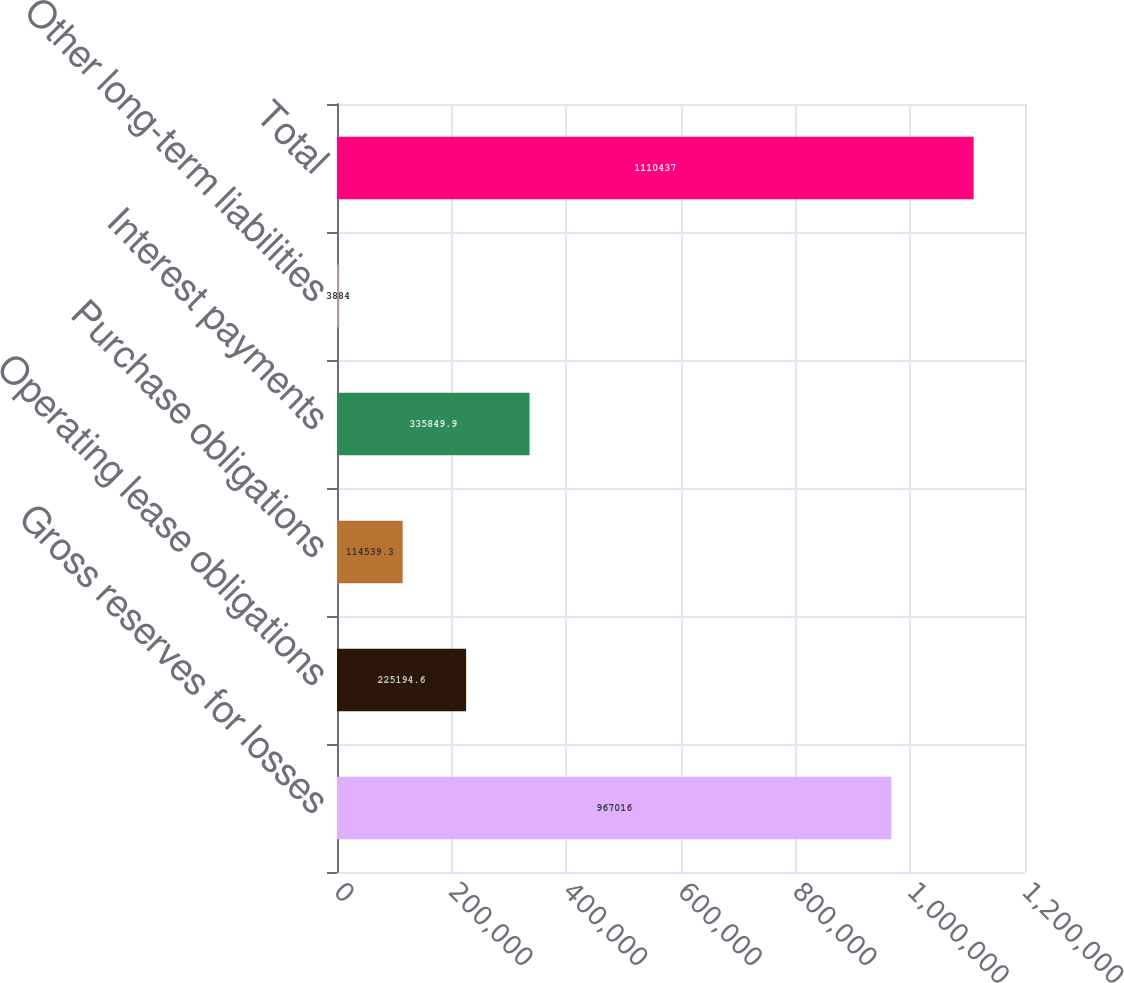Convert chart. <chart><loc_0><loc_0><loc_500><loc_500><bar_chart><fcel>Gross reserves for losses<fcel>Operating lease obligations<fcel>Purchase obligations<fcel>Interest payments<fcel>Other long-term liabilities<fcel>Total<nl><fcel>967016<fcel>225195<fcel>114539<fcel>335850<fcel>3884<fcel>1.11044e+06<nl></chart> 